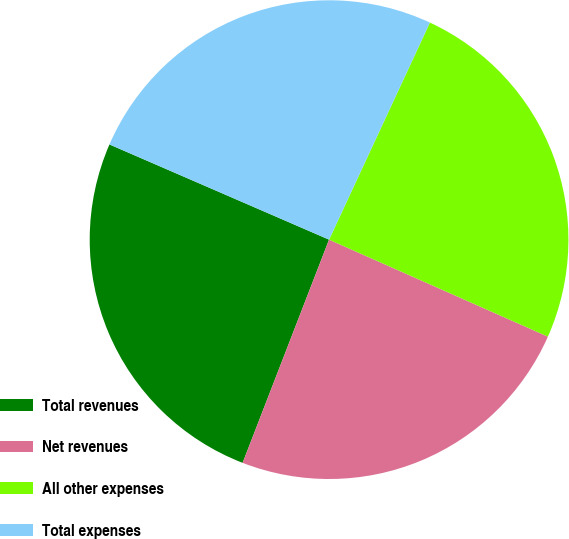Convert chart. <chart><loc_0><loc_0><loc_500><loc_500><pie_chart><fcel>Total revenues<fcel>Net revenues<fcel>All other expenses<fcel>Total expenses<nl><fcel>25.63%<fcel>24.24%<fcel>24.72%<fcel>25.41%<nl></chart> 